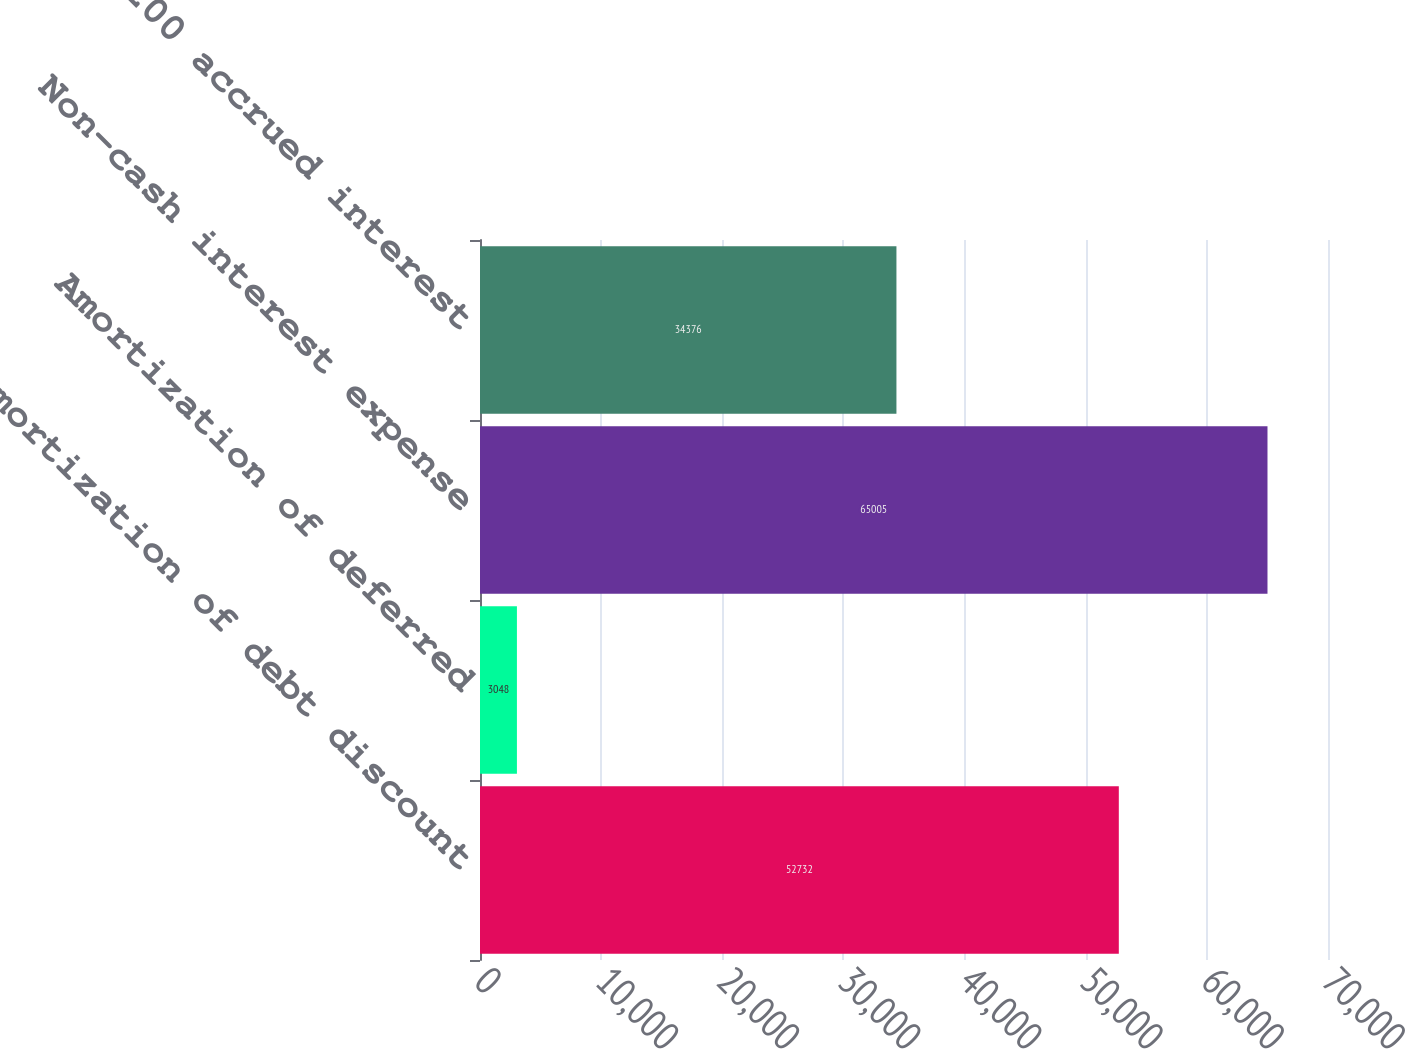Convert chart to OTSL. <chart><loc_0><loc_0><loc_500><loc_500><bar_chart><fcel>Amortization of debt discount<fcel>Amortization of deferred<fcel>Non-cash interest expense<fcel>200 accrued interest<nl><fcel>52732<fcel>3048<fcel>65005<fcel>34376<nl></chart> 